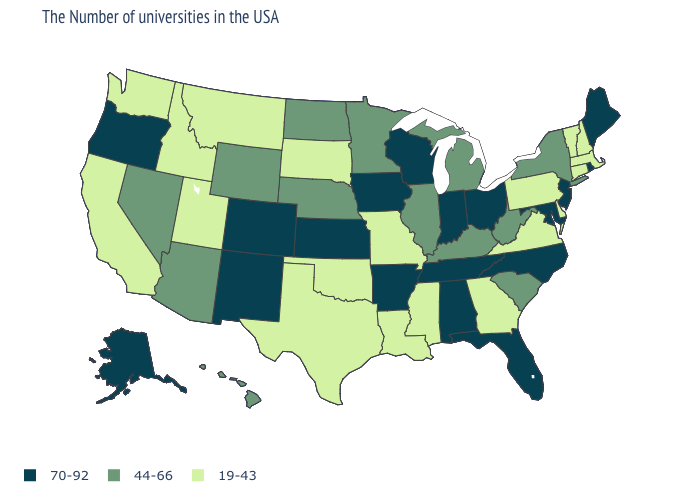Does Massachusetts have the highest value in the Northeast?
Keep it brief. No. What is the lowest value in the USA?
Give a very brief answer. 19-43. Does Massachusetts have a lower value than Maryland?
Be succinct. Yes. What is the highest value in the USA?
Quick response, please. 70-92. Which states have the lowest value in the MidWest?
Concise answer only. Missouri, South Dakota. Name the states that have a value in the range 19-43?
Quick response, please. Massachusetts, New Hampshire, Vermont, Connecticut, Delaware, Pennsylvania, Virginia, Georgia, Mississippi, Louisiana, Missouri, Oklahoma, Texas, South Dakota, Utah, Montana, Idaho, California, Washington. What is the value of Utah?
Answer briefly. 19-43. What is the highest value in the Northeast ?
Keep it brief. 70-92. What is the lowest value in the USA?
Quick response, please. 19-43. What is the value of Illinois?
Answer briefly. 44-66. What is the value of Nebraska?
Be succinct. 44-66. Name the states that have a value in the range 44-66?
Keep it brief. New York, South Carolina, West Virginia, Michigan, Kentucky, Illinois, Minnesota, Nebraska, North Dakota, Wyoming, Arizona, Nevada, Hawaii. Which states have the lowest value in the Northeast?
Keep it brief. Massachusetts, New Hampshire, Vermont, Connecticut, Pennsylvania. Among the states that border New Mexico , which have the lowest value?
Answer briefly. Oklahoma, Texas, Utah. 